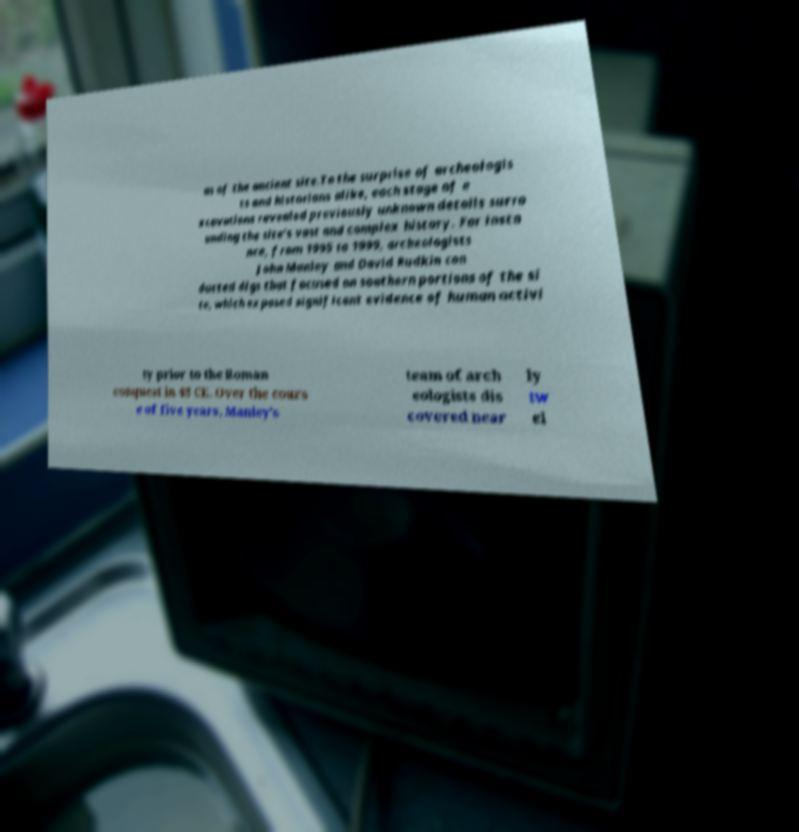What messages or text are displayed in this image? I need them in a readable, typed format. as of the ancient site.To the surprise of archeologis ts and historians alike, each stage of e xcavations revealed previously unknown details surro unding the site’s vast and complex history. For insta nce, from 1995 to 1999, archeologists John Manley and David Rudkin con ducted digs that focused on southern portions of the si te, which exposed significant evidence of human activi ty prior to the Roman conquest in 43 CE. Over the cours e of five years, Manley’s team of arch eologists dis covered near ly tw el 